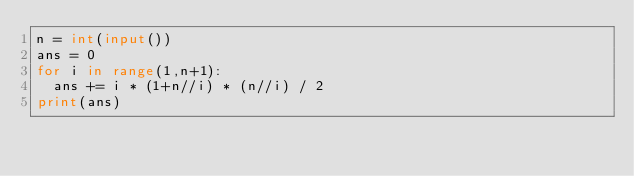Convert code to text. <code><loc_0><loc_0><loc_500><loc_500><_Python_>n = int(input())
ans = 0
for i in range(1,n+1):
  ans += i * (1+n//i) * (n//i) / 2
print(ans)</code> 